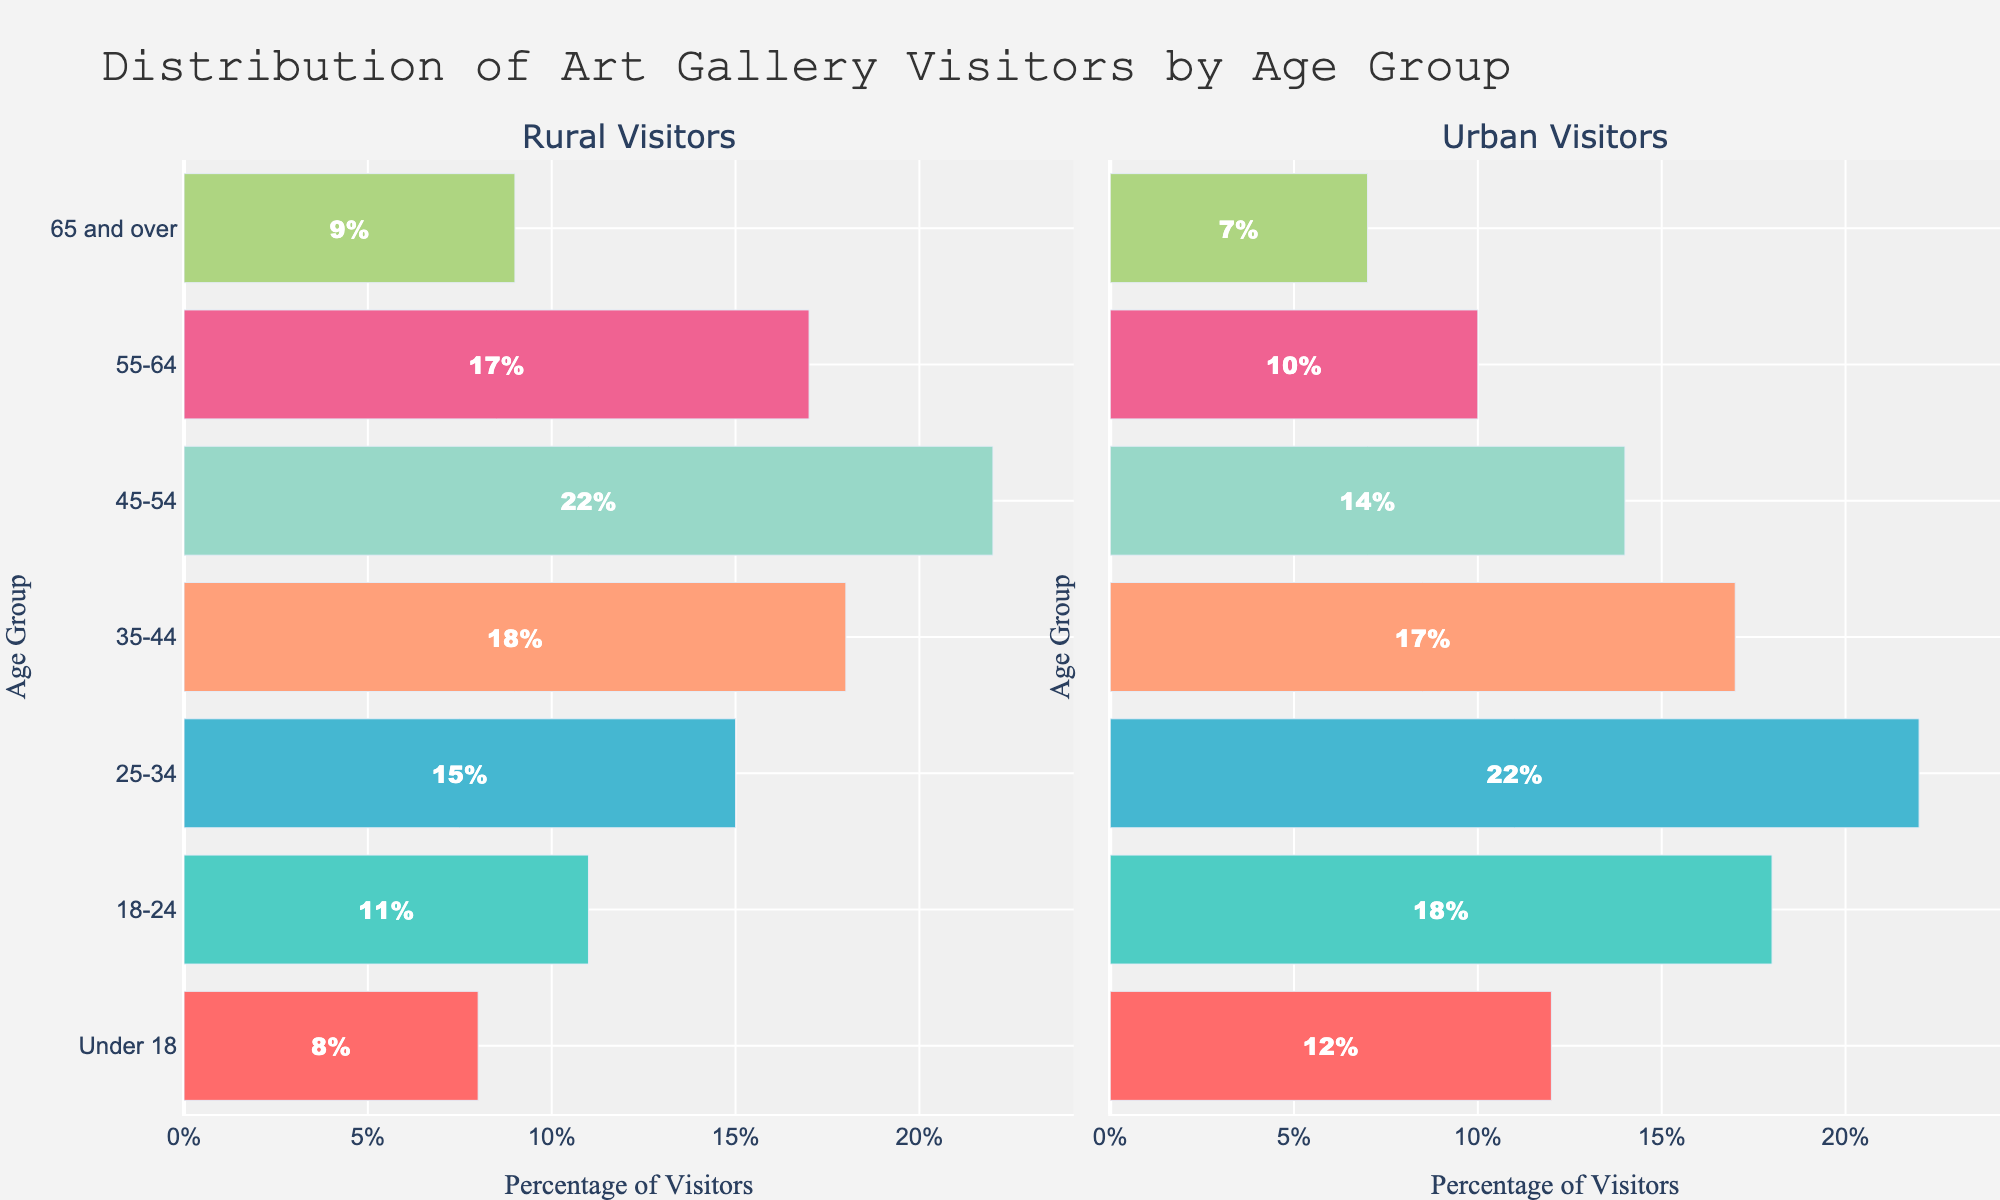How many more 18-24 visitors are there in urban areas compared to rural areas? The figure shows 11% of visitors in rural areas and 18% in urban areas. The difference is 18% - 11% = 7%.
Answer: 7% Which age group has the highest percentage of visitors in rural areas? The figure shows that the 45-54 age group has 22% of visitors, which is the highest percentage among all rural age groups.
Answer: 45-54 Compare the percentages of visitors under 18 in rural and urban areas. Which area has more? In rural areas, it's 8%, and in urban areas, it's 12%. Since 12% > 8%, urban areas have more visitors under 18.
Answer: Urban areas What is the total percentage of visitors in rural areas for the age groups 25-34 and 35-44 combined? The figure shows 15% for 25-34 and 18% for 35-44 in rural areas. Adding these gives 15% + 18% = 33%.
Answer: 33% Which color represents the age group 55-64 in both rural and urban visitors? The color for the 55-64 age group in both bar charts is a pinkish color (similar to #F06292) in the provided figure.
Answer: Pinkish What is the difference in visitor percentages between the 45-54 and 65 and over age groups in rural areas? The figure shows 22% for 45-54 and 9% for 65 and over. The difference is 22% - 9% = 13%.
Answer: 13% Which age group in urban areas shows a percentage close to the rural area’s under-18 group? The urban 65 and over group has 7%, which is close to rural under-18’s 8%.
Answer: 65 and over 